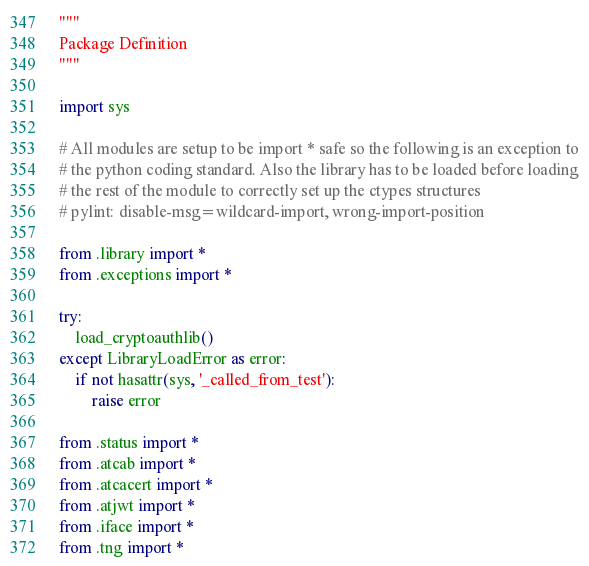<code> <loc_0><loc_0><loc_500><loc_500><_Python_>"""
Package Definition
"""

import sys

# All modules are setup to be import * safe so the following is an exception to
# the python coding standard. Also the library has to be loaded before loading
# the rest of the module to correctly set up the ctypes structures
# pylint: disable-msg=wildcard-import, wrong-import-position

from .library import *
from .exceptions import *

try:
    load_cryptoauthlib()
except LibraryLoadError as error:
    if not hasattr(sys, '_called_from_test'):
        raise error

from .status import *
from .atcab import *
from .atcacert import *
from .atjwt import *
from .iface import *
from .tng import *
</code> 